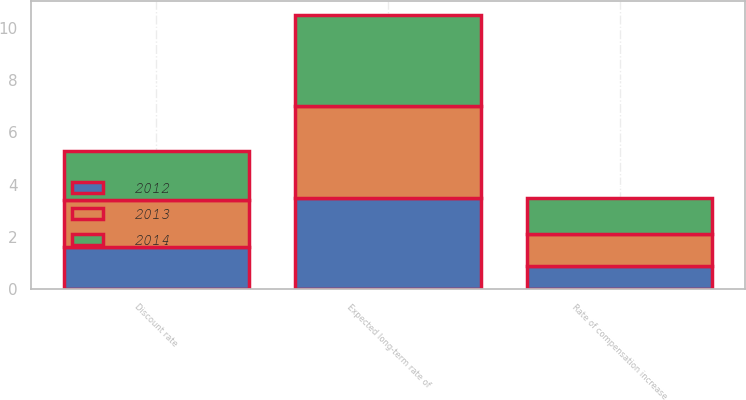<chart> <loc_0><loc_0><loc_500><loc_500><stacked_bar_chart><ecel><fcel>Discount rate<fcel>Expected long-term rate of<fcel>Rate of compensation increase<nl><fcel>2012<fcel>1.6<fcel>3.5<fcel>0.9<nl><fcel>2013<fcel>1.8<fcel>3.5<fcel>1.2<nl><fcel>2014<fcel>1.9<fcel>3.5<fcel>1.4<nl></chart> 